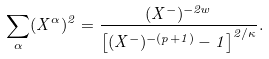<formula> <loc_0><loc_0><loc_500><loc_500>\sum _ { \alpha } ( X ^ { \alpha } ) ^ { 2 } = \frac { ( X ^ { - } ) ^ { - 2 w } } { \left [ ( X ^ { - } ) ^ { - ( p + 1 ) } - 1 \right ] ^ { 2 / \kappa } } .</formula> 